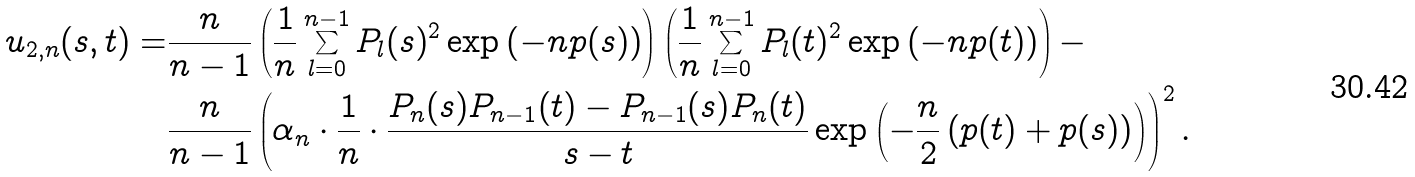Convert formula to latex. <formula><loc_0><loc_0><loc_500><loc_500>u _ { 2 , n } ( s , t ) = & \frac { n } { n - 1 } \left ( \frac { 1 } { n } \sum _ { l = 0 } ^ { n - 1 } P _ { l } ( s ) ^ { 2 } \exp \left ( - n p ( s ) \right ) \right ) \left ( \frac { 1 } { n } \sum _ { l = 0 } ^ { n - 1 } P _ { l } ( t ) ^ { 2 } \exp \left ( - n p ( t ) \right ) \right ) - \\ & \frac { n } { n - 1 } \left ( \alpha _ { n } \cdot \frac { 1 } { n } \cdot \frac { P _ { n } ( s ) P _ { n - 1 } ( t ) - P _ { n - 1 } ( s ) P _ { n } ( t ) } { s - t } \exp \left ( - \frac { n } { 2 } \left ( p ( t ) + p ( s ) \right ) \right ) \right ) ^ { 2 } .</formula> 